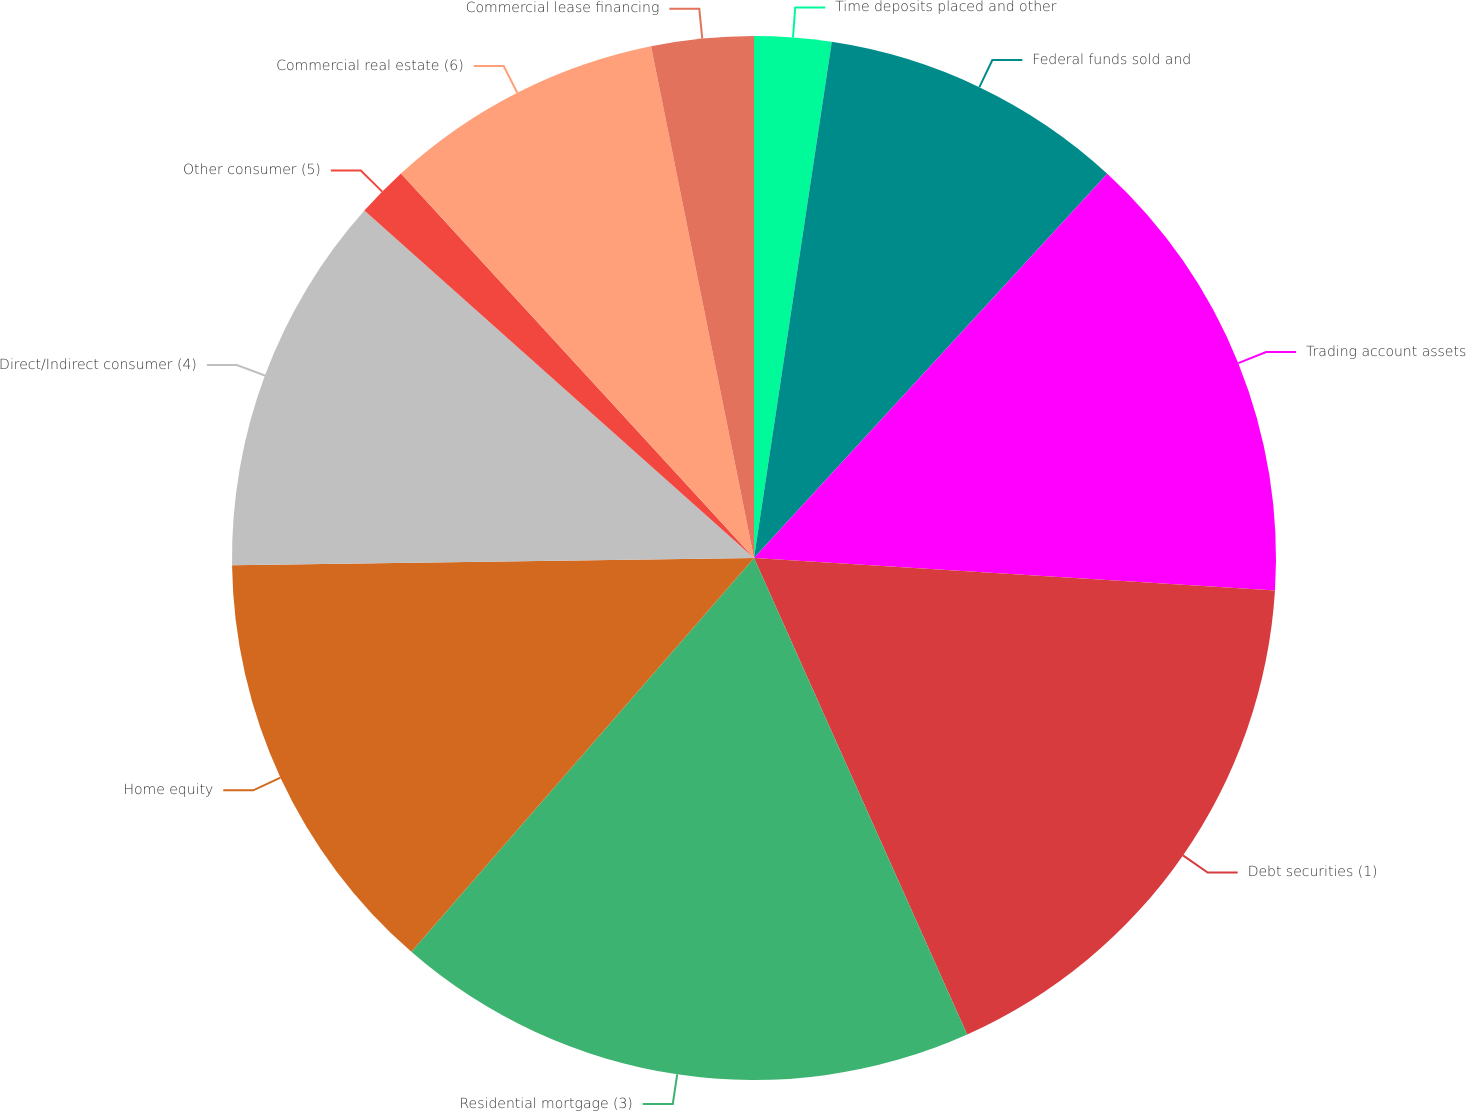Convert chart. <chart><loc_0><loc_0><loc_500><loc_500><pie_chart><fcel>Time deposits placed and other<fcel>Federal funds sold and<fcel>Trading account assets<fcel>Debt securities (1)<fcel>Residential mortgage (3)<fcel>Home equity<fcel>Direct/Indirect consumer (4)<fcel>Other consumer (5)<fcel>Commercial real estate (6)<fcel>Commercial lease financing<nl><fcel>2.38%<fcel>9.45%<fcel>14.16%<fcel>17.31%<fcel>18.09%<fcel>13.38%<fcel>11.81%<fcel>1.59%<fcel>8.66%<fcel>3.16%<nl></chart> 